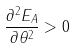<formula> <loc_0><loc_0><loc_500><loc_500>\frac { \partial ^ { 2 } E _ { A } } { \partial \theta ^ { 2 } } > 0</formula> 